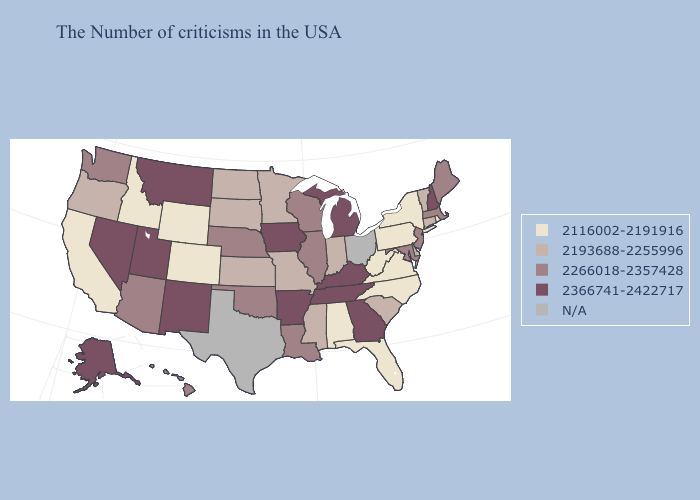Name the states that have a value in the range N/A?
Answer briefly. Ohio, Texas. Name the states that have a value in the range 2266018-2357428?
Write a very short answer. Maine, Massachusetts, New Jersey, Maryland, Wisconsin, Illinois, Louisiana, Nebraska, Oklahoma, Arizona, Washington, Hawaii. Does South Carolina have the lowest value in the USA?
Be succinct. No. What is the highest value in states that border North Dakota?
Answer briefly. 2366741-2422717. Among the states that border Arkansas , which have the lowest value?
Quick response, please. Mississippi, Missouri. Does Maine have the highest value in the Northeast?
Concise answer only. No. Among the states that border North Dakota , which have the lowest value?
Be succinct. Minnesota, South Dakota. What is the lowest value in the South?
Concise answer only. 2116002-2191916. Among the states that border Alabama , which have the highest value?
Be succinct. Georgia, Tennessee. What is the value of New Hampshire?
Give a very brief answer. 2366741-2422717. Among the states that border Texas , does Oklahoma have the lowest value?
Write a very short answer. Yes. What is the value of Pennsylvania?
Quick response, please. 2116002-2191916. Does the map have missing data?
Answer briefly. Yes. Name the states that have a value in the range 2116002-2191916?
Be succinct. Rhode Island, New York, Pennsylvania, Virginia, North Carolina, West Virginia, Florida, Alabama, Wyoming, Colorado, Idaho, California. 